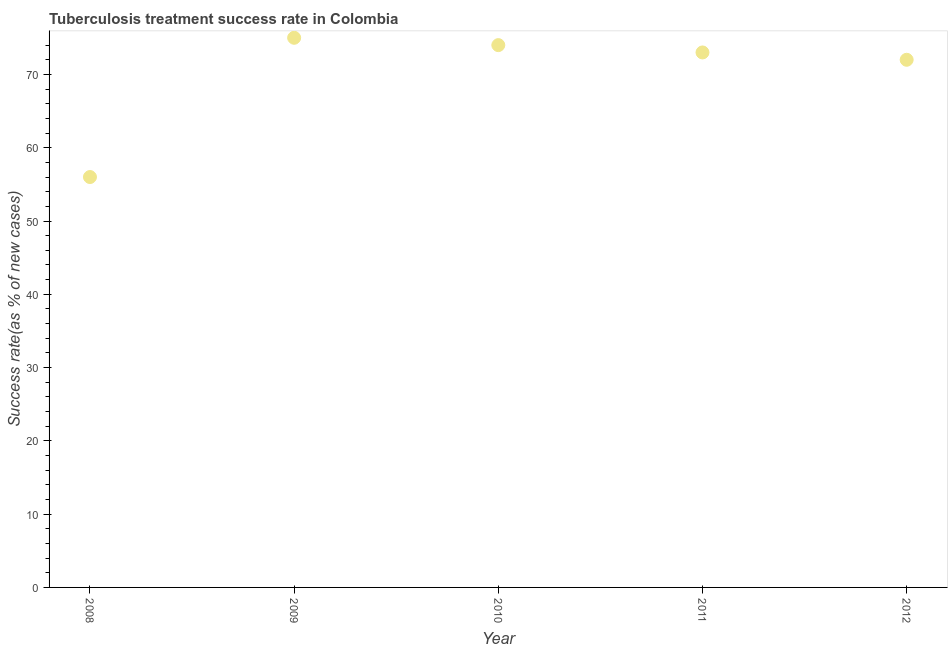What is the tuberculosis treatment success rate in 2012?
Give a very brief answer. 72. Across all years, what is the maximum tuberculosis treatment success rate?
Give a very brief answer. 75. Across all years, what is the minimum tuberculosis treatment success rate?
Provide a succinct answer. 56. In which year was the tuberculosis treatment success rate maximum?
Your answer should be compact. 2009. What is the sum of the tuberculosis treatment success rate?
Ensure brevity in your answer.  350. What is the difference between the tuberculosis treatment success rate in 2009 and 2011?
Ensure brevity in your answer.  2. Do a majority of the years between 2010 and 2008 (inclusive) have tuberculosis treatment success rate greater than 24 %?
Keep it short and to the point. No. What is the ratio of the tuberculosis treatment success rate in 2009 to that in 2011?
Offer a terse response. 1.03. What is the difference between the highest and the lowest tuberculosis treatment success rate?
Offer a very short reply. 19. Does the tuberculosis treatment success rate monotonically increase over the years?
Your answer should be compact. No. How many dotlines are there?
Your response must be concise. 1. How many years are there in the graph?
Offer a terse response. 5. What is the difference between two consecutive major ticks on the Y-axis?
Your response must be concise. 10. Does the graph contain any zero values?
Keep it short and to the point. No. Does the graph contain grids?
Provide a succinct answer. No. What is the title of the graph?
Give a very brief answer. Tuberculosis treatment success rate in Colombia. What is the label or title of the X-axis?
Provide a short and direct response. Year. What is the label or title of the Y-axis?
Offer a very short reply. Success rate(as % of new cases). What is the Success rate(as % of new cases) in 2008?
Offer a terse response. 56. What is the Success rate(as % of new cases) in 2010?
Your answer should be very brief. 74. What is the Success rate(as % of new cases) in 2011?
Offer a terse response. 73. What is the difference between the Success rate(as % of new cases) in 2008 and 2011?
Your answer should be very brief. -17. What is the difference between the Success rate(as % of new cases) in 2009 and 2011?
Your response must be concise. 2. What is the difference between the Success rate(as % of new cases) in 2009 and 2012?
Ensure brevity in your answer.  3. What is the difference between the Success rate(as % of new cases) in 2010 and 2011?
Offer a terse response. 1. What is the difference between the Success rate(as % of new cases) in 2010 and 2012?
Provide a succinct answer. 2. What is the difference between the Success rate(as % of new cases) in 2011 and 2012?
Your answer should be compact. 1. What is the ratio of the Success rate(as % of new cases) in 2008 to that in 2009?
Offer a terse response. 0.75. What is the ratio of the Success rate(as % of new cases) in 2008 to that in 2010?
Give a very brief answer. 0.76. What is the ratio of the Success rate(as % of new cases) in 2008 to that in 2011?
Make the answer very short. 0.77. What is the ratio of the Success rate(as % of new cases) in 2008 to that in 2012?
Offer a very short reply. 0.78. What is the ratio of the Success rate(as % of new cases) in 2009 to that in 2011?
Offer a terse response. 1.03. What is the ratio of the Success rate(as % of new cases) in 2009 to that in 2012?
Provide a short and direct response. 1.04. What is the ratio of the Success rate(as % of new cases) in 2010 to that in 2012?
Give a very brief answer. 1.03. 